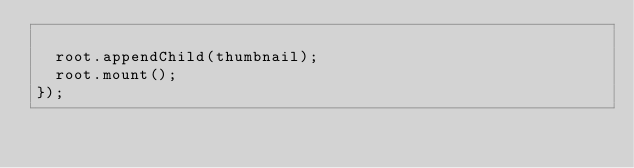Convert code to text. <code><loc_0><loc_0><loc_500><loc_500><_TypeScript_>
  root.appendChild(thumbnail);
  root.mount();
});
</code> 